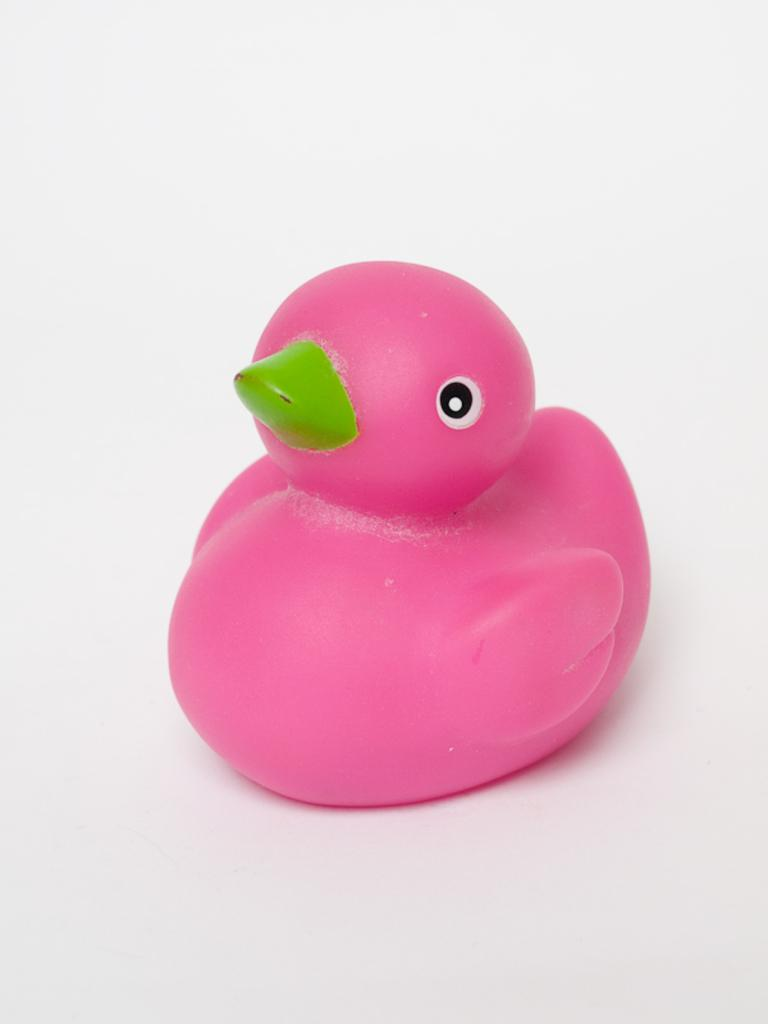What is the main subject of the image? The main subject of the image is a rubber duck. Can you describe the appearance of the rubber duck? The rubber duck is pink in color. What type of reward is the rubber duck offering in the image? The rubber duck is not offering any reward in the image; it is simply a rubber duck. What relation does the rubber duck have with the playground in the image? There is no playground present in the image, so the rubber duck does not have any relation to a playground. 